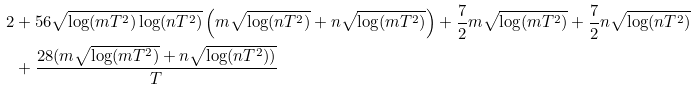<formula> <loc_0><loc_0><loc_500><loc_500>2 & + 5 6 \sqrt { \log ( m T ^ { 2 } ) \log ( n T ^ { 2 } ) } \left ( m \sqrt { \log ( n T ^ { 2 } ) } + n \sqrt { \log ( m T ^ { 2 } ) } \right ) + \frac { 7 } { 2 } m \sqrt { \log ( m T ^ { 2 } ) } + \frac { 7 } { 2 } n \sqrt { \log ( n T ^ { 2 } ) } \\ & + \frac { 2 8 ( m \sqrt { \log ( m T ^ { 2 } ) } + n \sqrt { \log ( n T ^ { 2 } ) ) } } { T }</formula> 